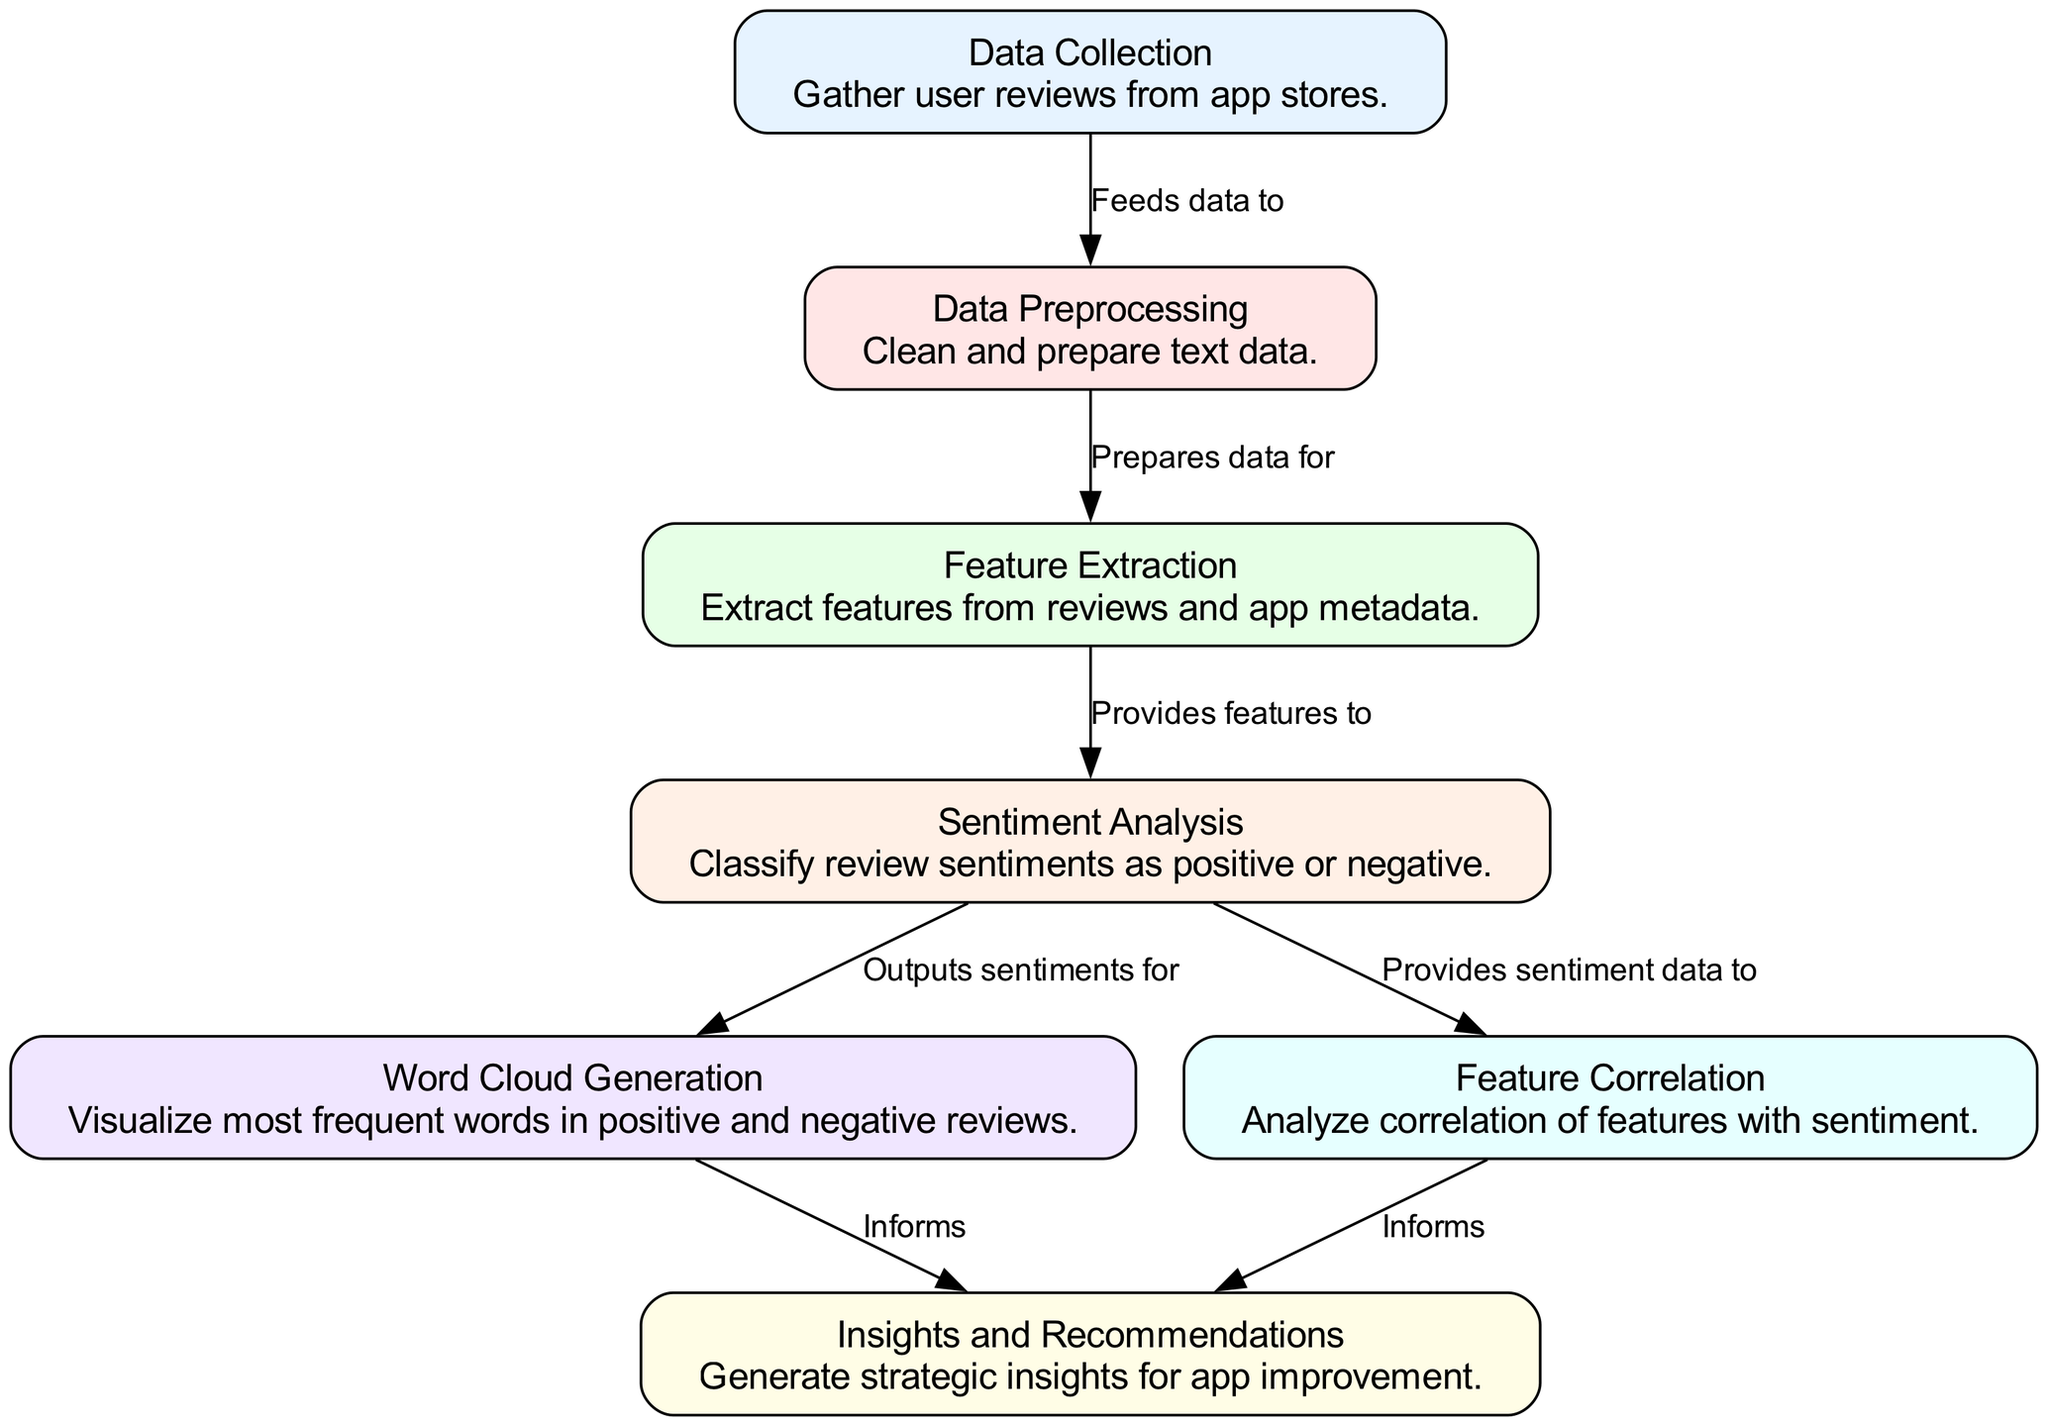What's the total number of nodes in the diagram? The diagram lists 7 distinct nodes as represented by their IDs, so counting each node gives a total of 7.
Answer: 7 What does the "Data Collection" node lead to? The "Data Collection" node feeds data to the "Data Preprocessing" node, as indicated by the directed edge between these two nodes.
Answer: Data Preprocessing Which node processes the feature extraction? The node labeled "Feature Extraction" directly follows the "Data Preprocessing" node, which indicates it is the node responsible for processing the feature extraction step once preprocessing is completed.
Answer: Feature Extraction How many edges are present in the diagram? By counting the directed edges listed in the diagram, we find a total of 6 edges connecting the nodes in the described flow of information.
Answer: 6 What two nodes inform the "Insights and Recommendations" outcome? The "Insights and Recommendations" node receives information from both the "Word Cloud Generation" and the "Feature Correlation" nodes, as shown by the directed edges leading into it.
Answer: Word Cloud Generation and Feature Correlation What is the primary output of the "Sentiment Analysis"? The "Sentiment Analysis" node outputs sentiments related to the reviews, which is directed toward the "Word Cloud Generation" node for further visualization of this sentiment data.
Answer: Sentiments Which node follows the "Sentiment Analysis"? The "Word Cloud Generation" node directly follows the "Sentiment Analysis" node by receiving its output of classified sentiments for the visualization step.
Answer: Word Cloud Generation What types of insights does the diagram aim to generate? The final node, "Insights and Recommendations," suggests that the diagram is structured to generate insights aimed at app improvement based on user sentiment analysis and feature correlation data.
Answer: Strategic insights for app improvement 